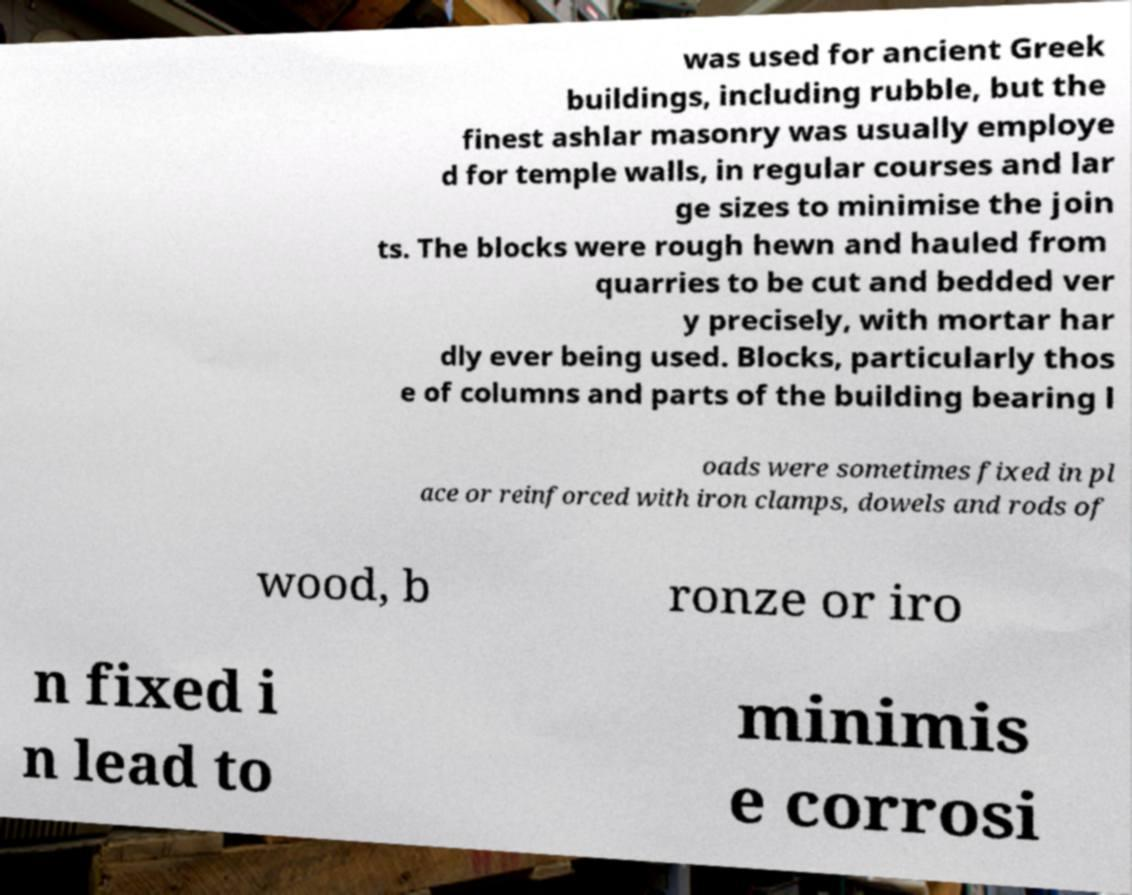I need the written content from this picture converted into text. Can you do that? was used for ancient Greek buildings, including rubble, but the finest ashlar masonry was usually employe d for temple walls, in regular courses and lar ge sizes to minimise the join ts. The blocks were rough hewn and hauled from quarries to be cut and bedded ver y precisely, with mortar har dly ever being used. Blocks, particularly thos e of columns and parts of the building bearing l oads were sometimes fixed in pl ace or reinforced with iron clamps, dowels and rods of wood, b ronze or iro n fixed i n lead to minimis e corrosi 